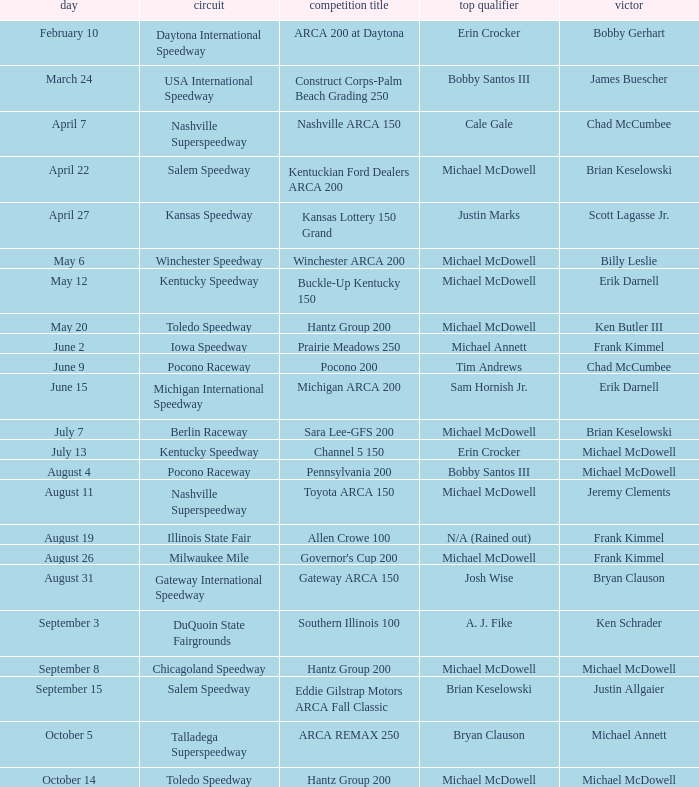Could you parse the entire table as a dict? {'header': ['day', 'circuit', 'competition title', 'top qualifier', 'victor'], 'rows': [['February 10', 'Daytona International Speedway', 'ARCA 200 at Daytona', 'Erin Crocker', 'Bobby Gerhart'], ['March 24', 'USA International Speedway', 'Construct Corps-Palm Beach Grading 250', 'Bobby Santos III', 'James Buescher'], ['April 7', 'Nashville Superspeedway', 'Nashville ARCA 150', 'Cale Gale', 'Chad McCumbee'], ['April 22', 'Salem Speedway', 'Kentuckian Ford Dealers ARCA 200', 'Michael McDowell', 'Brian Keselowski'], ['April 27', 'Kansas Speedway', 'Kansas Lottery 150 Grand', 'Justin Marks', 'Scott Lagasse Jr.'], ['May 6', 'Winchester Speedway', 'Winchester ARCA 200', 'Michael McDowell', 'Billy Leslie'], ['May 12', 'Kentucky Speedway', 'Buckle-Up Kentucky 150', 'Michael McDowell', 'Erik Darnell'], ['May 20', 'Toledo Speedway', 'Hantz Group 200', 'Michael McDowell', 'Ken Butler III'], ['June 2', 'Iowa Speedway', 'Prairie Meadows 250', 'Michael Annett', 'Frank Kimmel'], ['June 9', 'Pocono Raceway', 'Pocono 200', 'Tim Andrews', 'Chad McCumbee'], ['June 15', 'Michigan International Speedway', 'Michigan ARCA 200', 'Sam Hornish Jr.', 'Erik Darnell'], ['July 7', 'Berlin Raceway', 'Sara Lee-GFS 200', 'Michael McDowell', 'Brian Keselowski'], ['July 13', 'Kentucky Speedway', 'Channel 5 150', 'Erin Crocker', 'Michael McDowell'], ['August 4', 'Pocono Raceway', 'Pennsylvania 200', 'Bobby Santos III', 'Michael McDowell'], ['August 11', 'Nashville Superspeedway', 'Toyota ARCA 150', 'Michael McDowell', 'Jeremy Clements'], ['August 19', 'Illinois State Fair', 'Allen Crowe 100', 'N/A (Rained out)', 'Frank Kimmel'], ['August 26', 'Milwaukee Mile', "Governor's Cup 200", 'Michael McDowell', 'Frank Kimmel'], ['August 31', 'Gateway International Speedway', 'Gateway ARCA 150', 'Josh Wise', 'Bryan Clauson'], ['September 3', 'DuQuoin State Fairgrounds', 'Southern Illinois 100', 'A. J. Fike', 'Ken Schrader'], ['September 8', 'Chicagoland Speedway', 'Hantz Group 200', 'Michael McDowell', 'Michael McDowell'], ['September 15', 'Salem Speedway', 'Eddie Gilstrap Motors ARCA Fall Classic', 'Brian Keselowski', 'Justin Allgaier'], ['October 5', 'Talladega Superspeedway', 'ARCA REMAX 250', 'Bryan Clauson', 'Michael Annett'], ['October 14', 'Toledo Speedway', 'Hantz Group 200', 'Michael McDowell', 'Michael McDowell']]} Tell me the track for june 9 Pocono Raceway. 